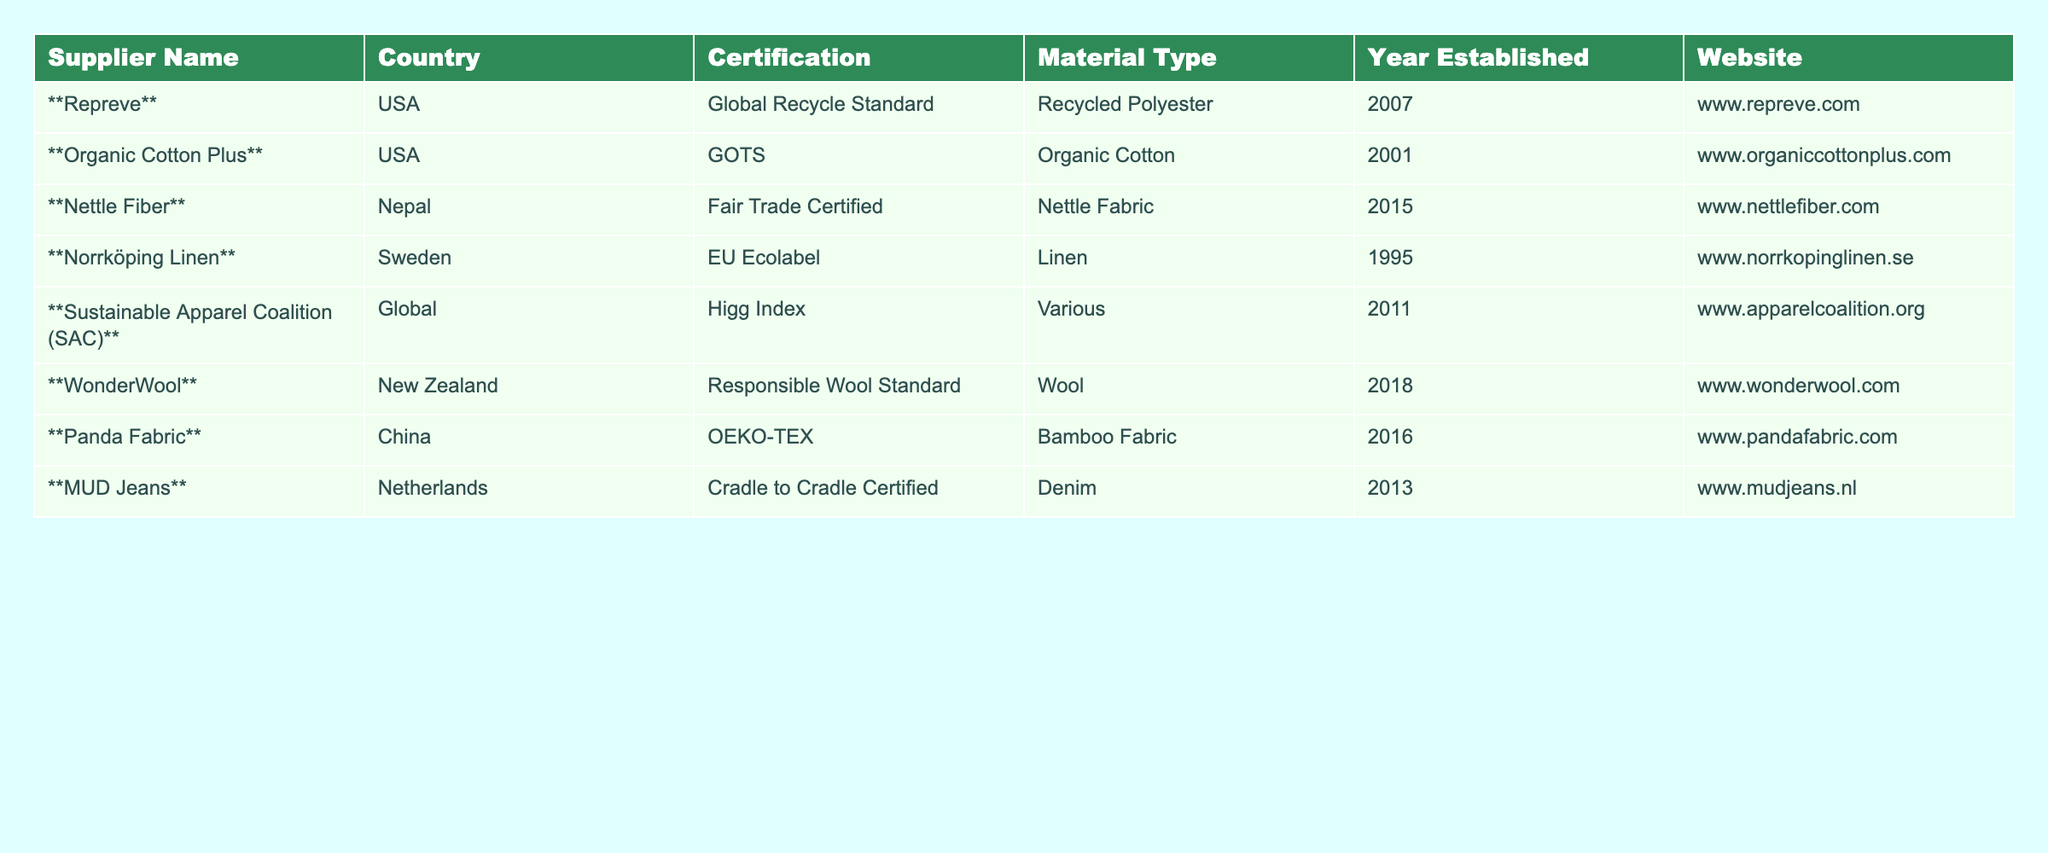What is the certification of Repreve? The table shows that Repreve has the certification of "Global Recycle Standard." This is directly listed under the Certification column for Repreve's row.
Answer: Global Recycle Standard Which material type is associated with Sustainable Apparel Coalition? The table indicates that Sustainable Apparel Coalition is associated with "Various" material types. This is stated in the Material Type column for that supplier.
Answer: Various How many suppliers are certified by GOTS? Looking at the table, only one supplier, Organic Cotton Plus, holds the GOTS certification. This is determined by checking the Certification column for matches to "GOTS."
Answer: 1 Which country has the highest number of suppliers listed in the table? Upon reviewing the table, the USA has the highest count with two suppliers: Repreve and Organic Cotton Plus. This is verified by counting the occurrences of each country in the Country column.
Answer: USA Is WonderWool certified under any wool standard? The table confirms that WonderWool is certified under the "Responsible Wool Standard," as indicated in the Certification column. This answers affirmatively to the question.
Answer: Yes What is the average year established of the suppliers? To determine the average, we need to sum the years established [(2007 + 2001 + 2015 + 1995 + 2011 + 2018 + 2016 + 2013) = 1596] and then divide by the number of suppliers (8). Thus, the average year established is 1596/8 = 199.5, resulting in a year of approximately 199.5, noting that it refers to years before the current year, indicating 1998.5.
Answer: 1998.5 Which supplier has the oldest establishment year? By inspecting the Year Established column, we see that Norrköping Linen is the oldest, established in 1995, as it's the highest number listed in that column.
Answer: Norrköping Linen Are there any suppliers that provide bamboo fabric? The table shows that Panda Fabric provides bamboo fabric, as listed in the Material Type column for that supplier. Hence, the answer to the question is affirmative.
Answer: Yes What is the difference in establishment years between the oldest and the youngest supplier? The oldest supplier is Norrköping Linen (1995) and the youngest is WonderWool (2018). The difference is calculated as 2018 - 1995 = 23 years. This determines how long apart they were established.
Answer: 23 years How many suppliers have a certification that is recognized on a global scale? The certifications labeled as globally recognized are GOTS, Higg Index, Global Recycle Standard, and Fair Trade Certified. Counting these gives us the total of four suppliers with such certifications: Organic Cotton Plus, Sustainable Apparel Coalition, Repreve, and Nettle Fiber.
Answer: 4 